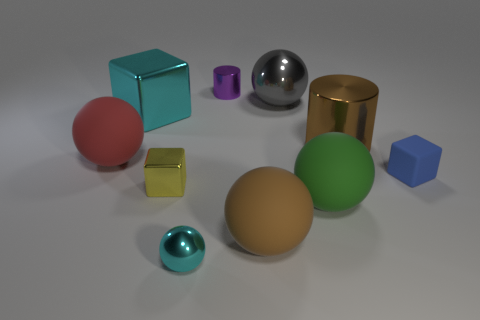The large sphere that is both behind the tiny matte block and in front of the big brown cylinder is what color?
Keep it short and to the point. Red. Are there more big balls that are in front of the small yellow metallic object than large brown matte spheres that are to the left of the cyan sphere?
Your response must be concise. Yes. Does the cyan object in front of the yellow metal cube have the same size as the small matte block?
Offer a very short reply. Yes. There is a metal cube in front of the rubber sphere left of the tiny purple metallic cylinder; what number of tiny cyan metallic objects are right of it?
Provide a short and direct response. 1. There is a metal thing that is both to the right of the purple metal cylinder and in front of the big shiny cube; what is its size?
Provide a short and direct response. Large. What number of other objects are the same shape as the large green thing?
Your response must be concise. 4. There is a yellow object; what number of small purple objects are in front of it?
Ensure brevity in your answer.  0. Are there fewer small yellow shiny blocks that are on the left side of the big red rubber sphere than tiny cubes that are to the left of the purple cylinder?
Provide a short and direct response. Yes. What is the shape of the tiny cyan metal thing in front of the big brown shiny cylinder left of the blue matte cube that is right of the purple thing?
Ensure brevity in your answer.  Sphere. What is the shape of the tiny metallic thing that is both in front of the big shiny sphere and behind the small sphere?
Give a very brief answer. Cube. 